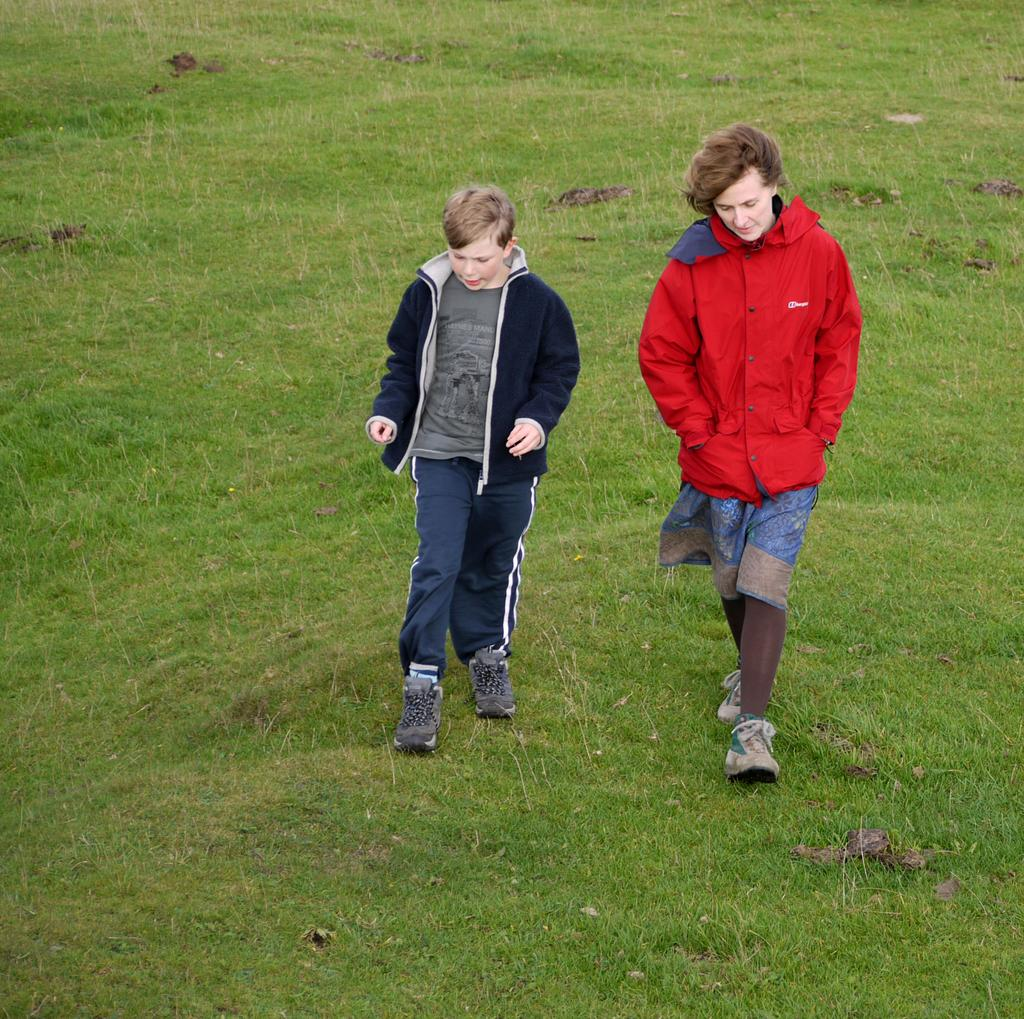Who are the people present in the image? There is a woman and a boy in the image. What are the woman and the boy doing in the image? The woman and the boy are walking on the ground. What type of surface are they walking on? There is grass on the ground. Where is the faucet located in the image? There is no faucet present in the image. What type of performance is happening on the stage in the image? There is no stage present in the image. 